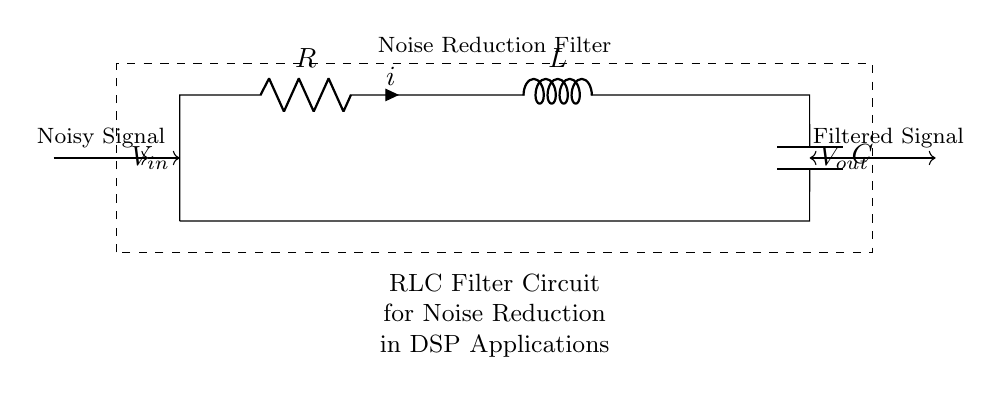What components are in this circuit? The circuit diagram shows a resistor, an inductor, and a capacitor, which are the primary components of an RLC circuit.
Answer: resistor, inductor, capacitor What is the input signal labeled as? The input signal is labeled as "V in," indicating it is the voltage input to the filter circuit.
Answer: V in What type of filter is represented in this diagram? The diagram represents a noise reduction filter, specifically an RLC filter designed to attenuate unwanted noise in a signal.
Answer: noise reduction filter What does "V out" represent in the circuit? "V out" refers to the output voltage of the circuit after it has been filtered, reflecting the desired signal with reduced noise.
Answer: V out How many energy storage elements are in the circuit? The circuit contains two energy storage elements: one inductor and one capacitor, both of which store energy in the electromagnetic and electric fields, respectively.
Answer: two What happens to the signal as it passes through the circuit? As the signal (noisy signal) passes through the RLC circuit, it undergoes filtering, which reduces noise and results in a cleaner output signal.
Answer: filtered signal What is the role of the resistor in this circuit? The resistor primarily serves to limit the current, help in damping the circuit, and is crucial for defining the overall behavior of the filter in terms of gain and phase.
Answer: limit current 